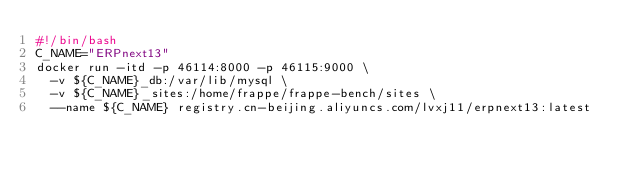<code> <loc_0><loc_0><loc_500><loc_500><_Bash_>#!/bin/bash
C_NAME="ERPnext13"
docker run -itd -p 46114:8000 -p 46115:9000 \
  -v ${C_NAME}_db:/var/lib/mysql \
  -v ${C_NAME}_sites:/home/frappe/frappe-bench/sites \
  --name ${C_NAME} registry.cn-beijing.aliyuncs.com/lvxj11/erpnext13:latest
</code> 